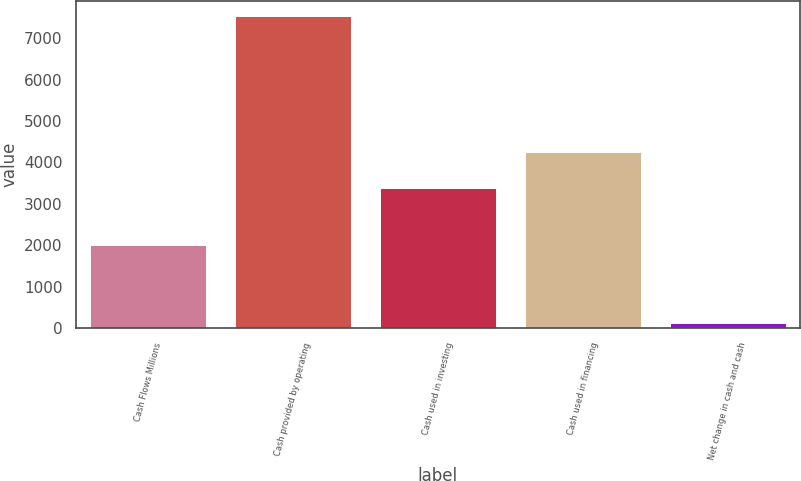<chart> <loc_0><loc_0><loc_500><loc_500><bar_chart><fcel>Cash Flows Millions<fcel>Cash provided by operating<fcel>Cash used in investing<fcel>Cash used in financing<fcel>Net change in cash and cash<nl><fcel>2016<fcel>7525<fcel>3393<fcel>4246<fcel>114<nl></chart> 